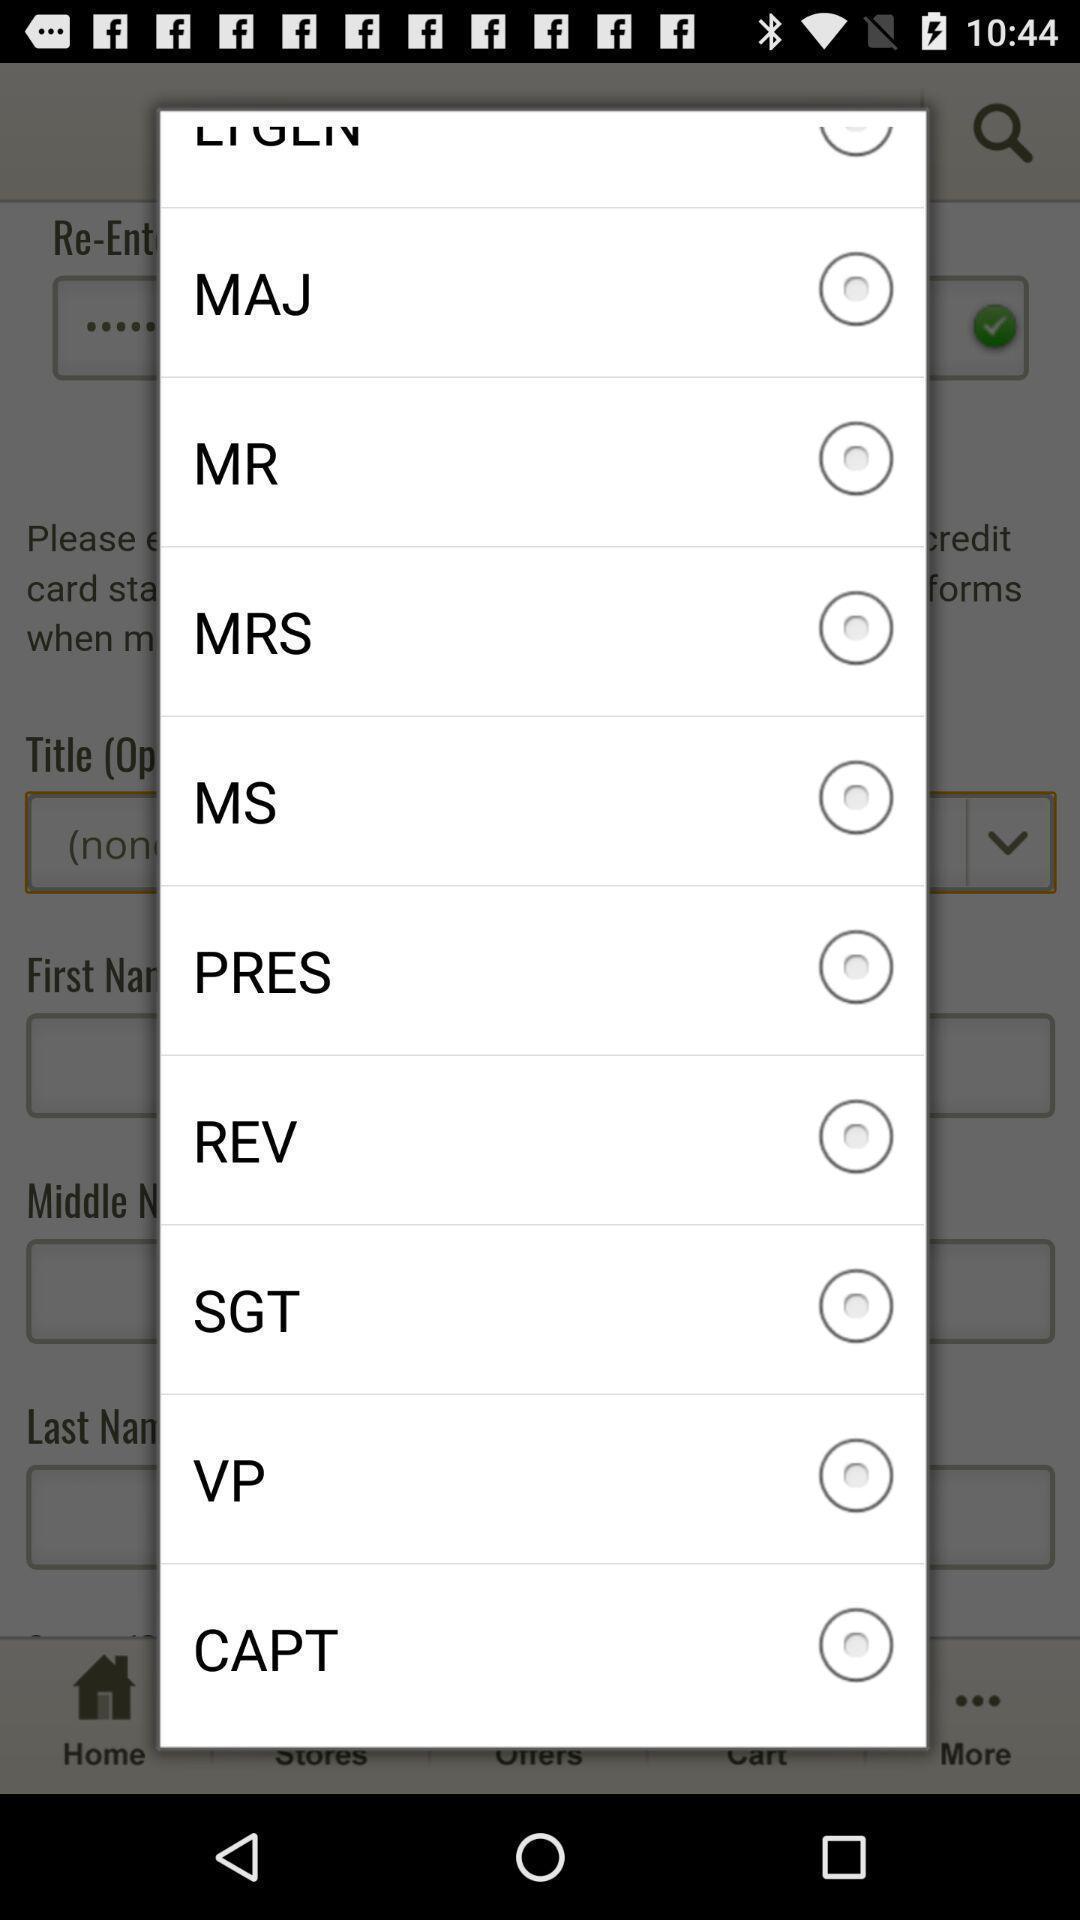Provide a textual representation of this image. Selection popup. 